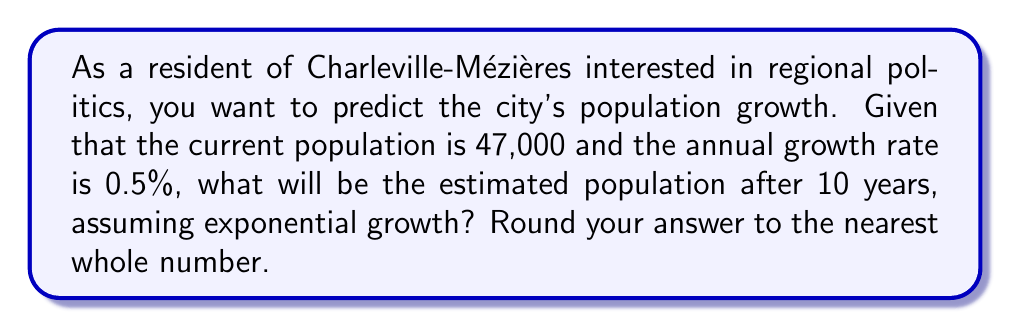Could you help me with this problem? To solve this problem, we'll use the exponential growth model:

$$P(t) = P_0 \cdot (1 + r)^t$$

Where:
$P(t)$ is the population at time $t$
$P_0$ is the initial population
$r$ is the annual growth rate (as a decimal)
$t$ is the number of years

Step 1: Identify the given values
$P_0 = 47,000$
$r = 0.005$ (0.5% expressed as a decimal)
$t = 10$ years

Step 2: Plug the values into the formula
$$P(10) = 47,000 \cdot (1 + 0.005)^{10}$$

Step 3: Calculate the result
$$P(10) = 47,000 \cdot (1.005)^{10}$$
$$P(10) = 47,000 \cdot 1.0511$$
$$P(10) = 49,401.7$$

Step 4: Round to the nearest whole number
$P(10) \approx 49,402$

Therefore, the estimated population of Charleville-Mézières after 10 years will be approximately 49,402 people.
Answer: 49,402 